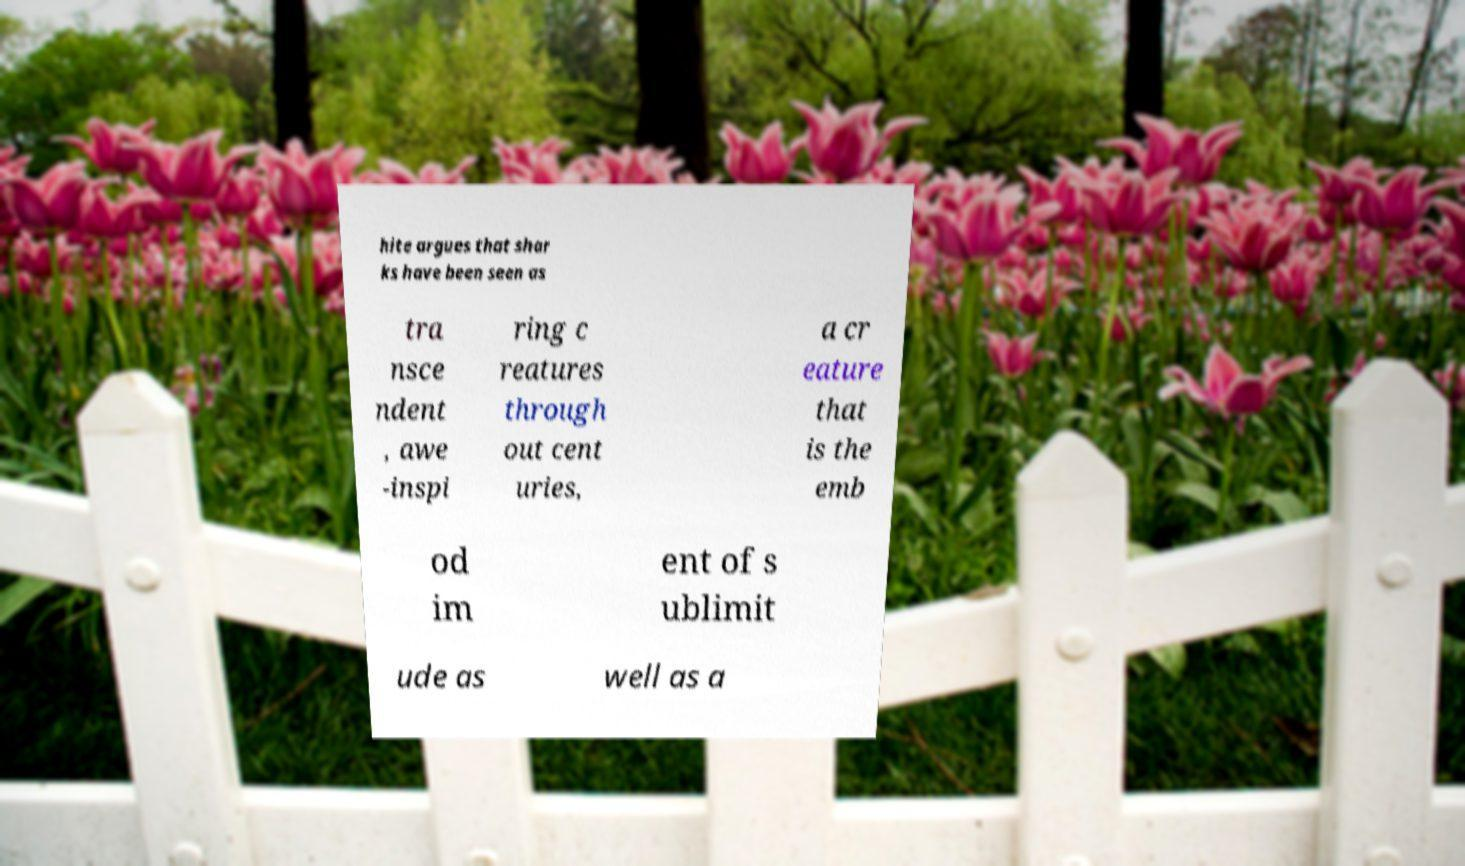For documentation purposes, I need the text within this image transcribed. Could you provide that? hite argues that shar ks have been seen as tra nsce ndent , awe -inspi ring c reatures through out cent uries, a cr eature that is the emb od im ent of s ublimit ude as well as a 